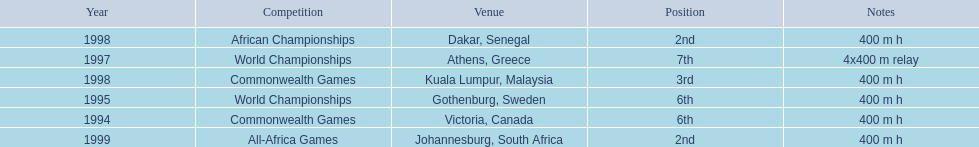How long was the relay at the 1997 world championships that ken harden ran 4x400 m relay. 